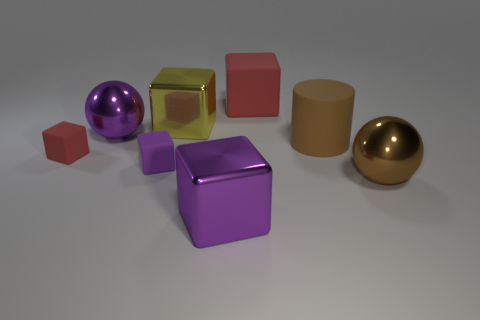Subtract all cyan blocks. Subtract all green cylinders. How many blocks are left? 5 Add 1 big red objects. How many objects exist? 9 Subtract all cubes. How many objects are left? 3 Subtract all brown rubber cylinders. Subtract all big red matte things. How many objects are left? 6 Add 1 big purple metallic spheres. How many big purple metallic spheres are left? 2 Add 5 matte blocks. How many matte blocks exist? 8 Subtract 0 cyan cylinders. How many objects are left? 8 